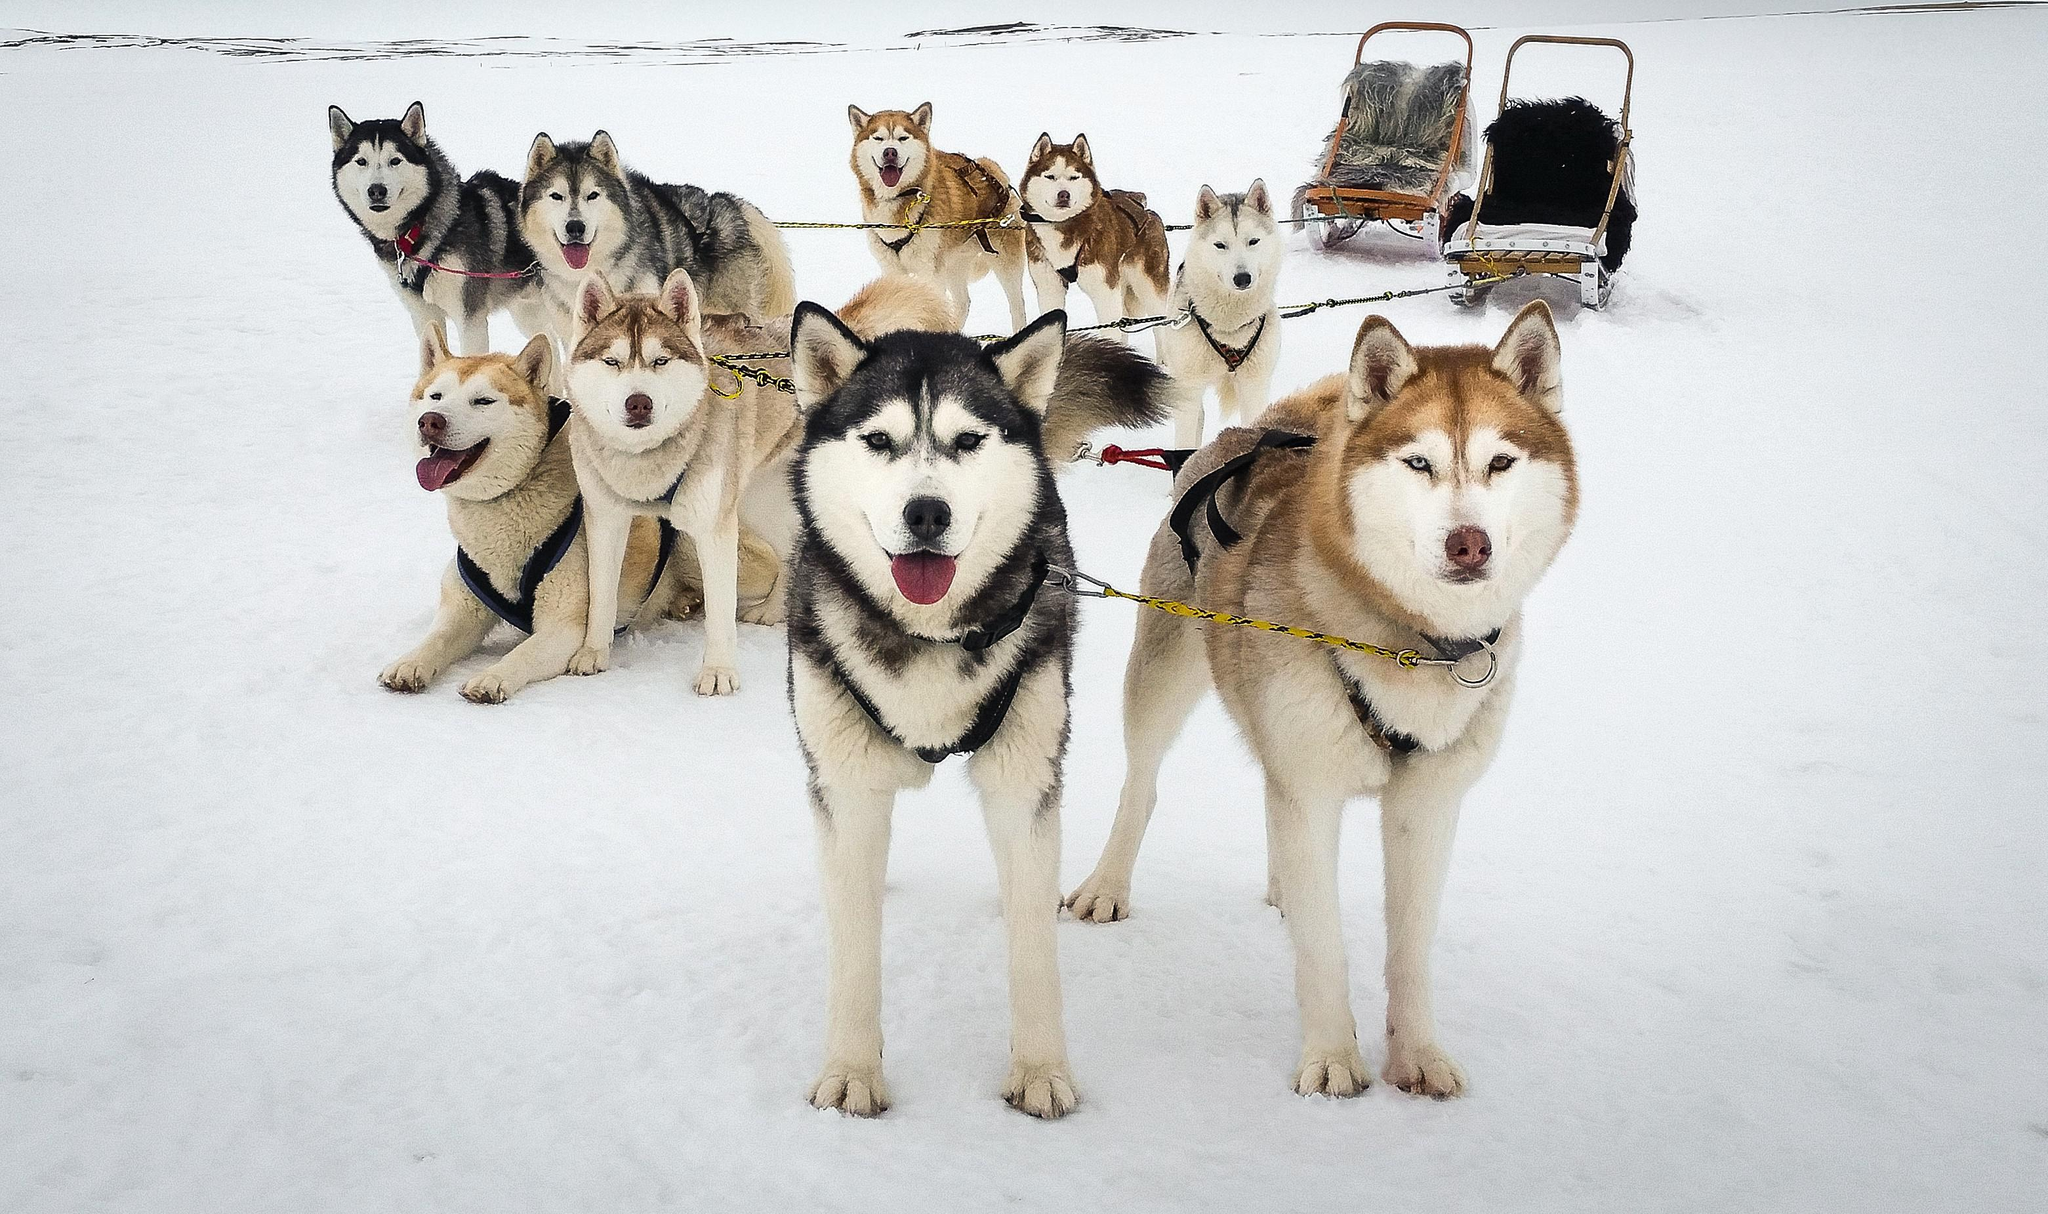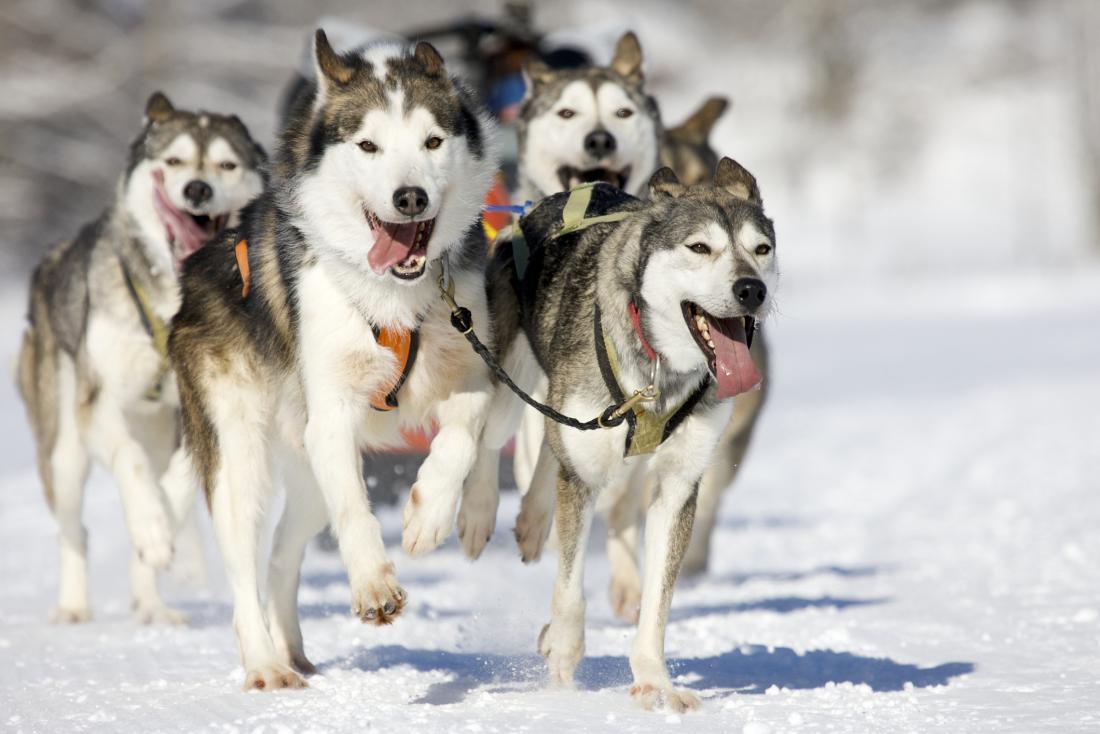The first image is the image on the left, the second image is the image on the right. Analyze the images presented: Is the assertion "There are dogs wearing colorful paw coverups." valid? Answer yes or no. No. The first image is the image on the left, the second image is the image on the right. Analyze the images presented: Is the assertion "There are dogs wearing colored socks in at least one image." valid? Answer yes or no. No. 